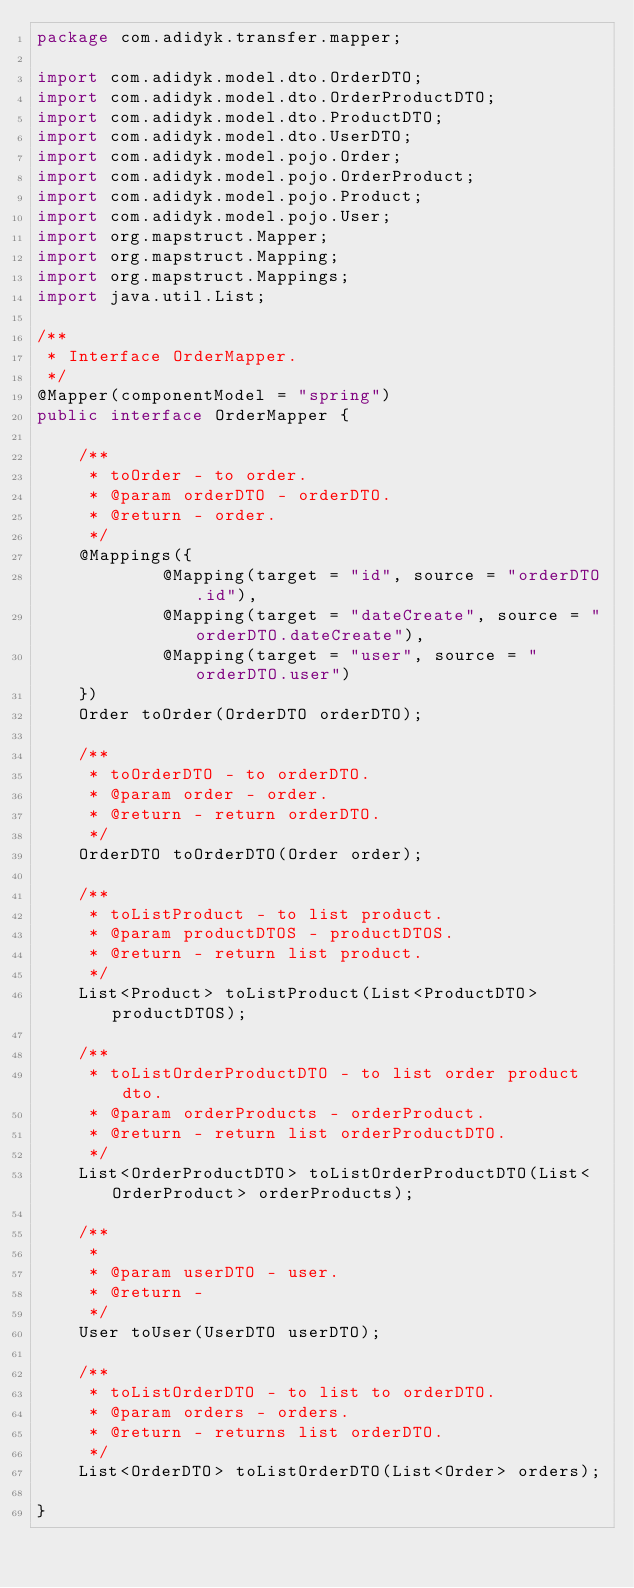Convert code to text. <code><loc_0><loc_0><loc_500><loc_500><_Java_>package com.adidyk.transfer.mapper;

import com.adidyk.model.dto.OrderDTO;
import com.adidyk.model.dto.OrderProductDTO;
import com.adidyk.model.dto.ProductDTO;
import com.adidyk.model.dto.UserDTO;
import com.adidyk.model.pojo.Order;
import com.adidyk.model.pojo.OrderProduct;
import com.adidyk.model.pojo.Product;
import com.adidyk.model.pojo.User;
import org.mapstruct.Mapper;
import org.mapstruct.Mapping;
import org.mapstruct.Mappings;
import java.util.List;

/**
 * Interface OrderMapper.
 */
@Mapper(componentModel = "spring")
public interface OrderMapper {

    /**
     * toOrder - to order.
     * @param orderDTO - orderDTO.
     * @return - order.
     */
    @Mappings({
            @Mapping(target = "id", source = "orderDTO.id"),
            @Mapping(target = "dateCreate", source = "orderDTO.dateCreate"),
            @Mapping(target = "user", source = "orderDTO.user")
    })
    Order toOrder(OrderDTO orderDTO);

    /**
     * toOrderDTO - to orderDTO.
     * @param order - order.
     * @return - return orderDTO.
     */
    OrderDTO toOrderDTO(Order order);

    /**
     * toListProduct - to list product.
     * @param productDTOS - productDTOS.
     * @return - return list product.
     */
    List<Product> toListProduct(List<ProductDTO> productDTOS);

    /**
     * toListOrderProductDTO - to list order product dto.
     * @param orderProducts - orderProduct.
     * @return - return list orderProductDTO.
     */
    List<OrderProductDTO> toListOrderProductDTO(List<OrderProduct> orderProducts);

    /**
     *
     * @param userDTO - user.
     * @return -
     */
    User toUser(UserDTO userDTO);

    /**
     * toListOrderDTO - to list to orderDTO.
     * @param orders - orders.
     * @return - returns list orderDTO.
     */
    List<OrderDTO> toListOrderDTO(List<Order> orders);

}
</code> 